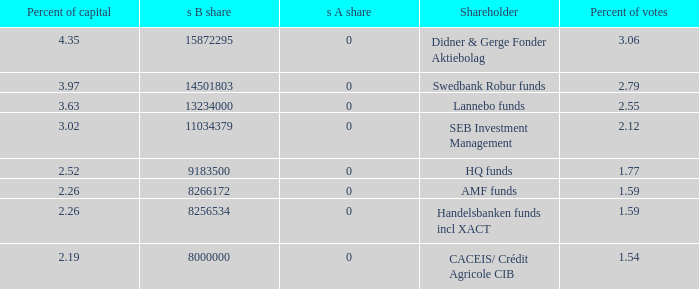What is the s B share for Handelsbanken funds incl XACT? 8256534.0. 